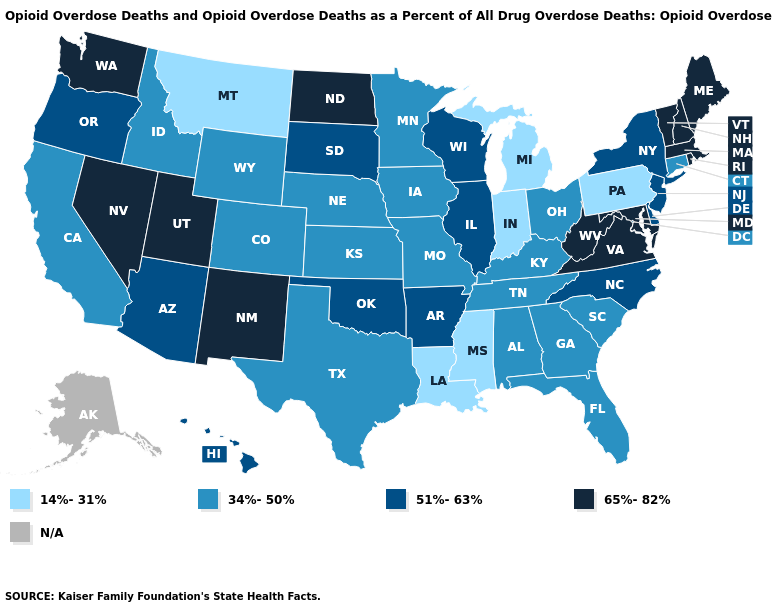Among the states that border Texas , which have the highest value?
Give a very brief answer. New Mexico. What is the value of Iowa?
Quick response, please. 34%-50%. Does Hawaii have the lowest value in the USA?
Write a very short answer. No. What is the value of Georgia?
Be succinct. 34%-50%. Name the states that have a value in the range 14%-31%?
Answer briefly. Indiana, Louisiana, Michigan, Mississippi, Montana, Pennsylvania. Does Utah have the highest value in the West?
Short answer required. Yes. Among the states that border Virginia , does Tennessee have the lowest value?
Be succinct. Yes. Name the states that have a value in the range 14%-31%?
Answer briefly. Indiana, Louisiana, Michigan, Mississippi, Montana, Pennsylvania. Name the states that have a value in the range N/A?
Be succinct. Alaska. What is the highest value in the USA?
Short answer required. 65%-82%. What is the value of Kansas?
Give a very brief answer. 34%-50%. Does the map have missing data?
Short answer required. Yes. Name the states that have a value in the range N/A?
Be succinct. Alaska. 